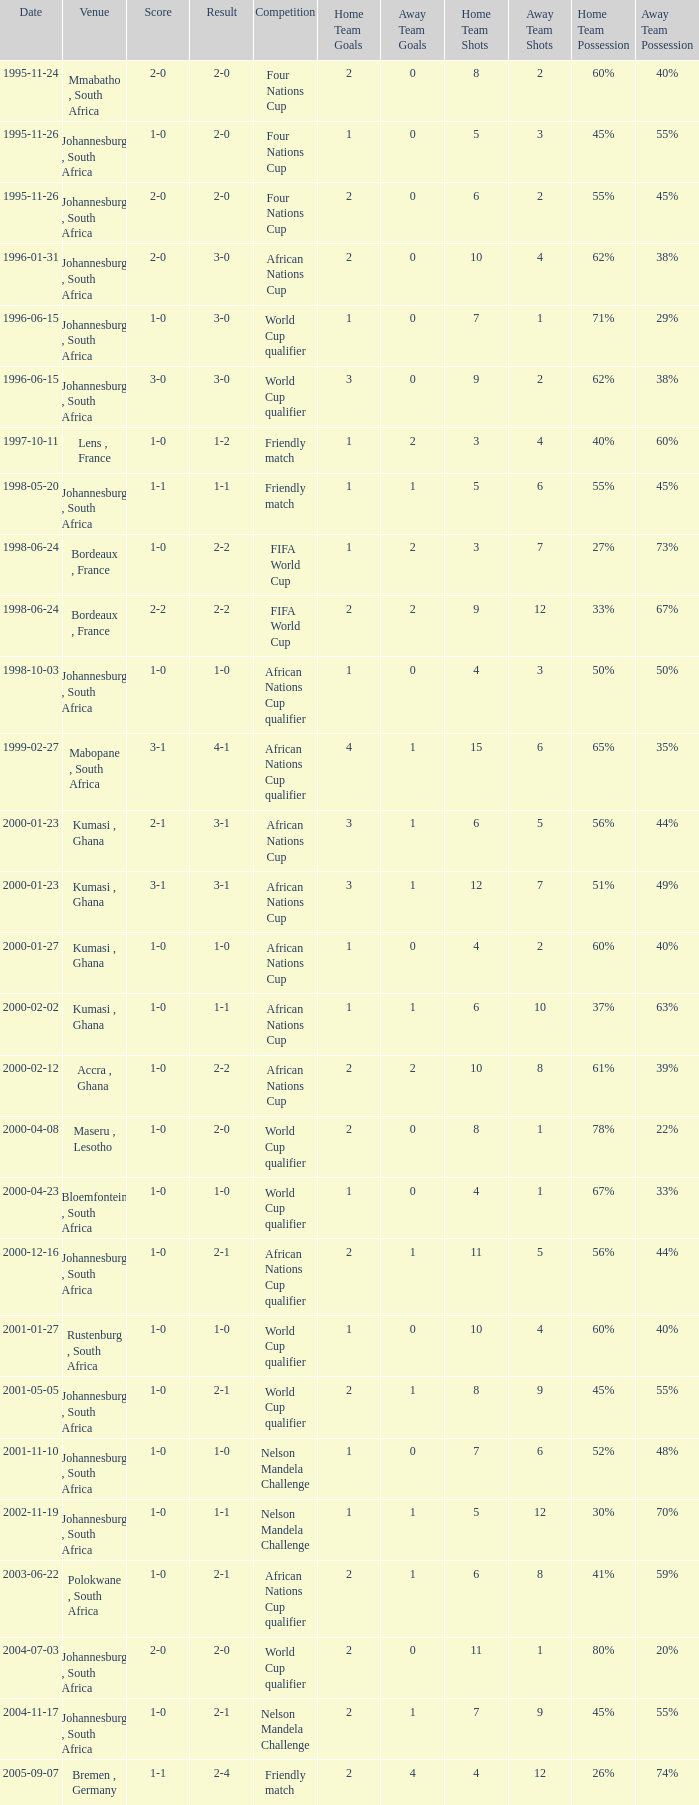What is the Date of the Fifa World Cup with a Score of 1-0? 1998-06-24. 